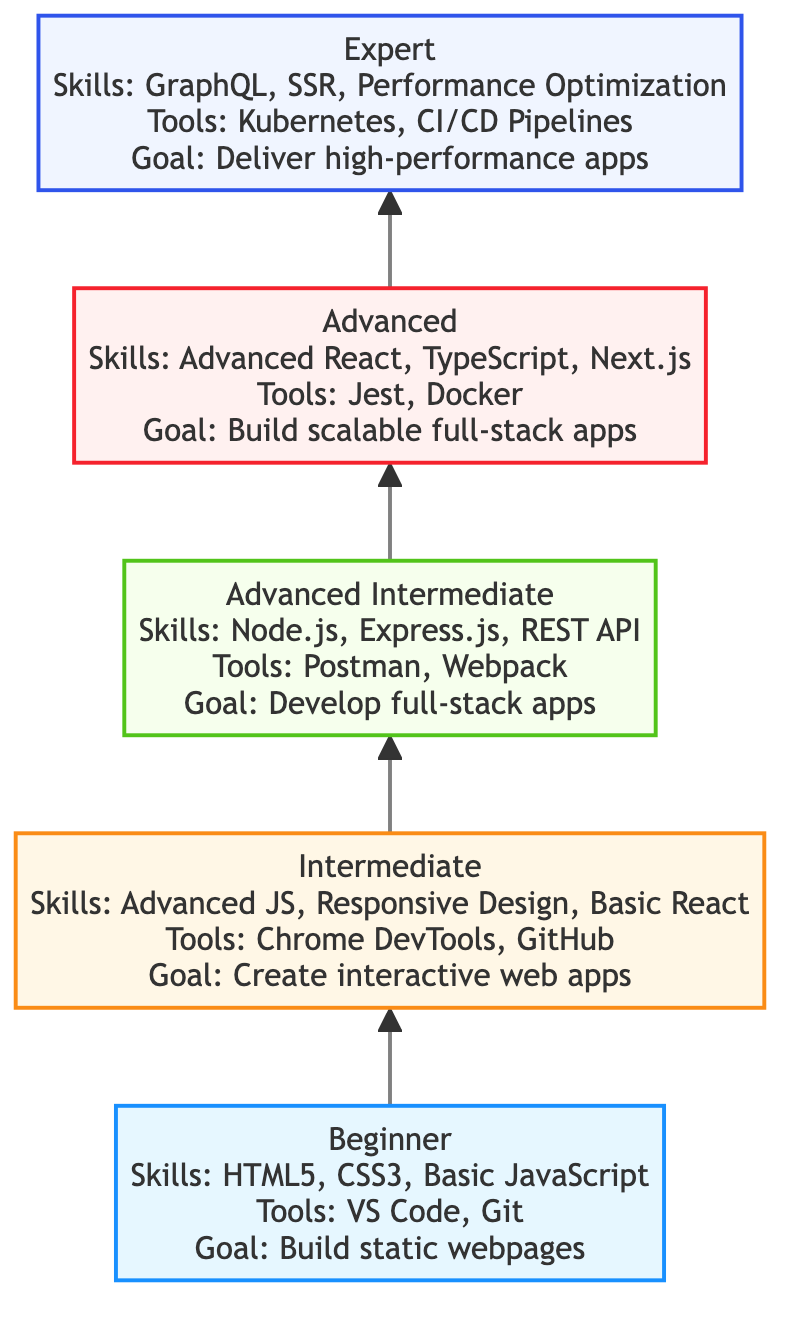What is the skill level associated with HTML5 and CSS3? HTML5 and CSS3 are listed under the "Beginner" level in the diagram, which indicates that these skills are fundamental and the starting point for web development.
Answer: Beginner What tools are required at the Advanced Intermediate level? The Advanced Intermediate level lists "Postman" and "Webpack" as the tools required, which are necessary for full-stack application development.
Answer: Postman, Webpack How many skills are listed for the Expert level? The Expert level lists three skills: "GraphQL," "Server-Side Rendering," and "Performance Optimization," so there are three skills in total for this level.
Answer: 3 What is the primary goal of an Intermediate web developer? The Intermediate level states the goal is to "Create interactive and responsive web applications," which focuses on enhancing user experience with dynamic features.
Answer: Create interactive and responsive web applications Which level focuses on building scalable full-stack applications? The "Advanced" level emphasizes building scalable full-stack applications, incorporating advanced technologies and frameworks.
Answer: Advanced Which tool is common between the Beginner and Intermediate levels? The "Git" tool is mentioned in both the Beginner and Intermediate levels, signifying its importance throughout the development journey.
Answer: Git What is the flow direction in the diagram? The flow direction in the diagram is from the bottom to the top, signifying the progression from beginner to expert levels in skills development.
Answer: Bottom to top How does the skill development progress from Advanced Intermediate to Advanced? The progression from Advanced Intermediate to Advanced requires a shift from technical aspects like REST API Development to more sophisticated skills such as Advanced React, indicating deeper specialization.
Answer: Advanced React, TypeScript, Next.js 